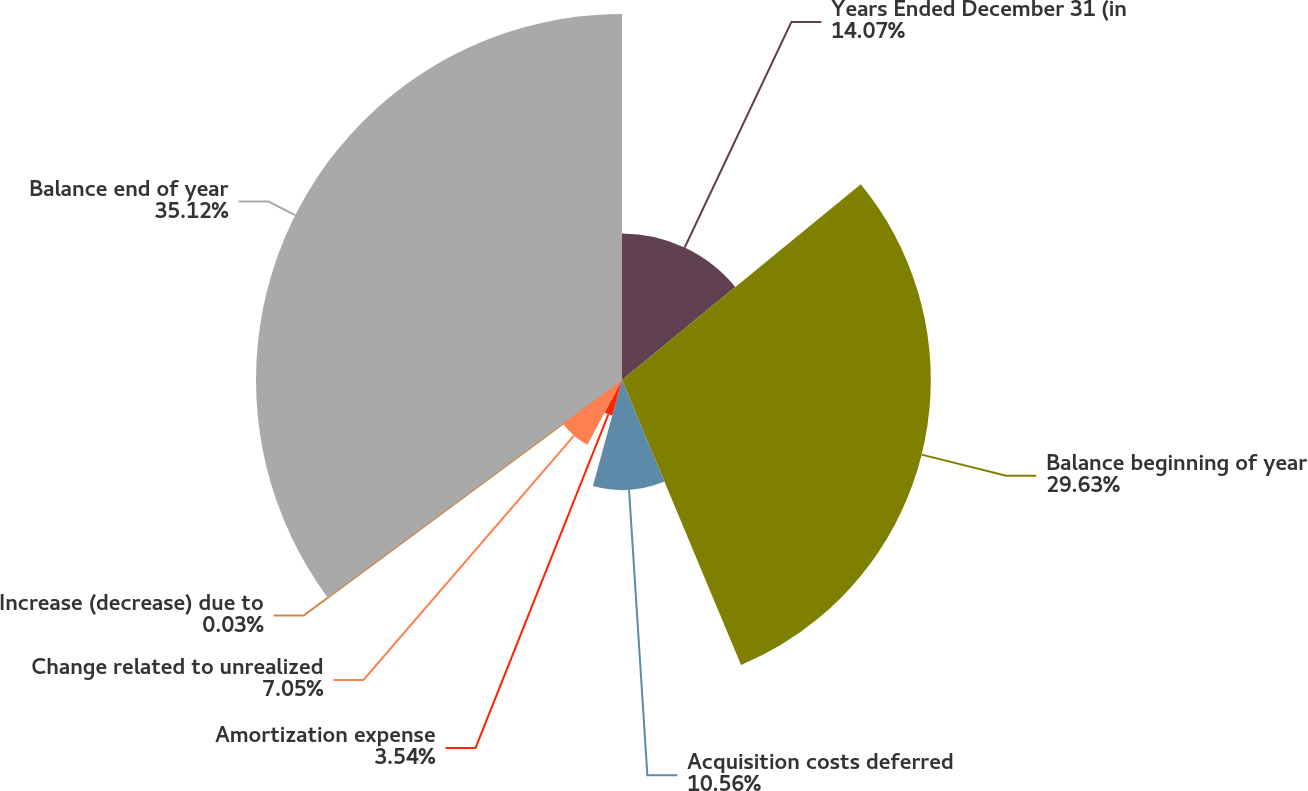<chart> <loc_0><loc_0><loc_500><loc_500><pie_chart><fcel>Years Ended December 31 (in<fcel>Balance beginning of year<fcel>Acquisition costs deferred<fcel>Amortization expense<fcel>Change related to unrealized<fcel>Increase (decrease) due to<fcel>Balance end of year<nl><fcel>14.07%<fcel>29.64%<fcel>10.56%<fcel>3.54%<fcel>7.05%<fcel>0.03%<fcel>35.13%<nl></chart> 